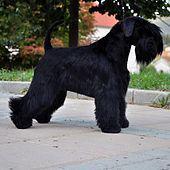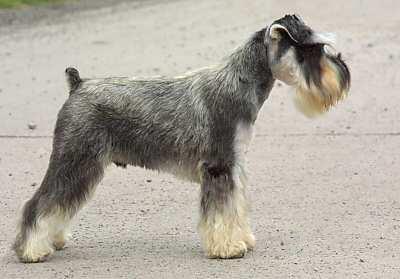The first image is the image on the left, the second image is the image on the right. Given the left and right images, does the statement "At least one image is a solo black dog." hold true? Answer yes or no. Yes. 